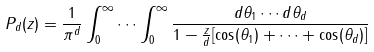<formula> <loc_0><loc_0><loc_500><loc_500>P _ { d } ( z ) = \frac { 1 } { \pi ^ { d } } \int _ { 0 } ^ { \infty } \cdots \int _ { 0 } ^ { \infty } \frac { d \theta _ { 1 } \cdots d \theta _ { d } } { 1 - \frac { z } { d } [ \cos ( \theta _ { 1 } ) + \cdots + \cos ( \theta _ { d } ) ] }</formula> 